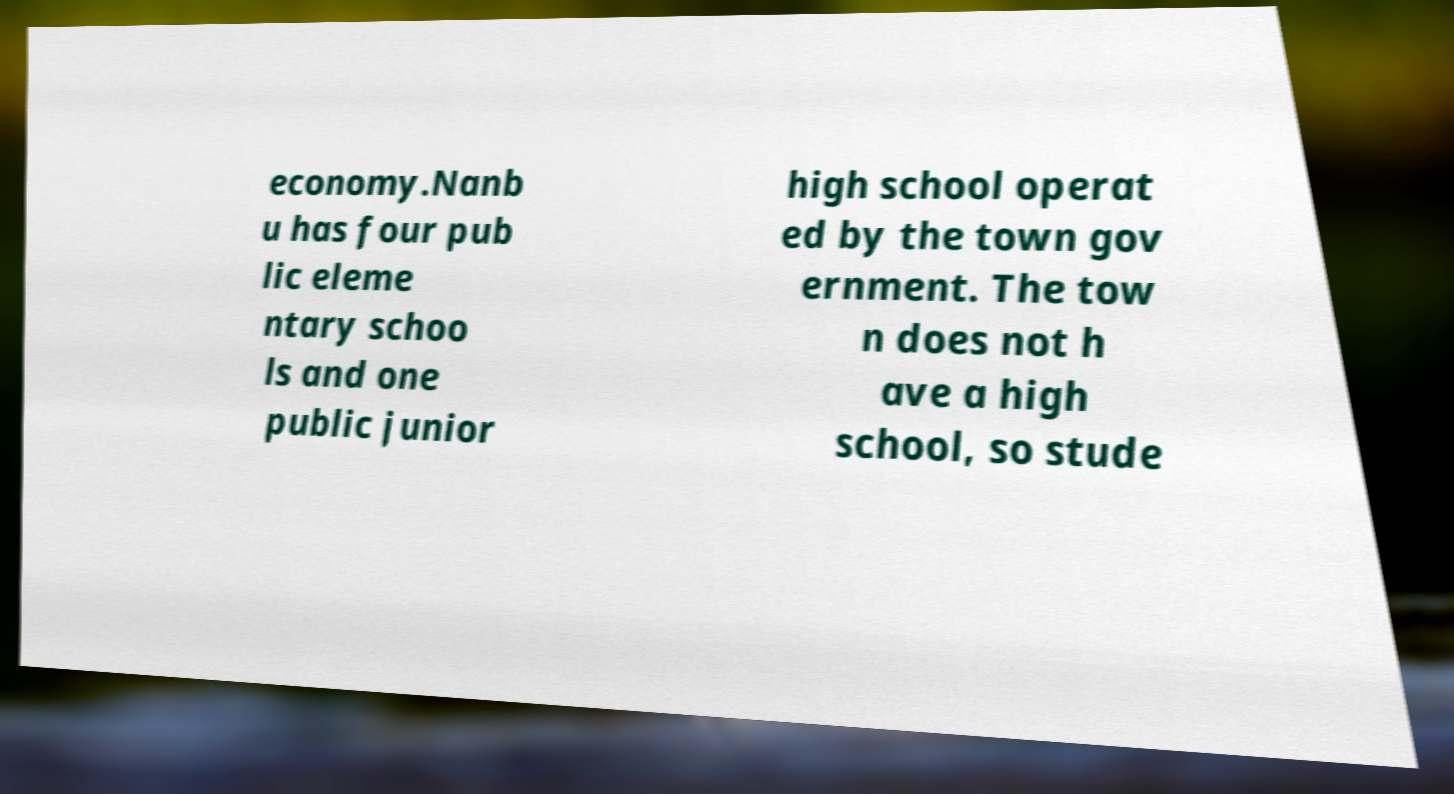Please read and relay the text visible in this image. What does it say? economy.Nanb u has four pub lic eleme ntary schoo ls and one public junior high school operat ed by the town gov ernment. The tow n does not h ave a high school, so stude 